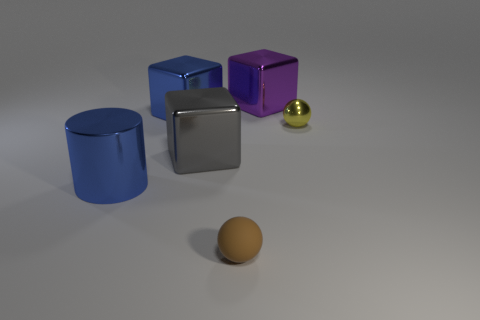What is the material of the tiny ball that is in front of the shiny ball?
Ensure brevity in your answer.  Rubber. Is the shape of the big gray metallic object the same as the brown thing?
Keep it short and to the point. No. There is a large cube that is right of the big cube in front of the metallic object right of the purple object; what is its color?
Provide a short and direct response. Purple. How many yellow objects are the same shape as the gray object?
Your answer should be compact. 0. There is a cube that is on the right side of the tiny brown thing to the right of the large cylinder; what size is it?
Ensure brevity in your answer.  Large. Does the brown matte object have the same size as the blue cylinder?
Provide a short and direct response. No. Are there any small brown balls in front of the sphere behind the big shiny cylinder that is in front of the gray cube?
Offer a terse response. Yes. The rubber object is what size?
Offer a very short reply. Small. How many yellow shiny things have the same size as the brown matte sphere?
Offer a very short reply. 1. There is a small yellow object that is the same shape as the tiny brown rubber object; what material is it?
Your response must be concise. Metal. 